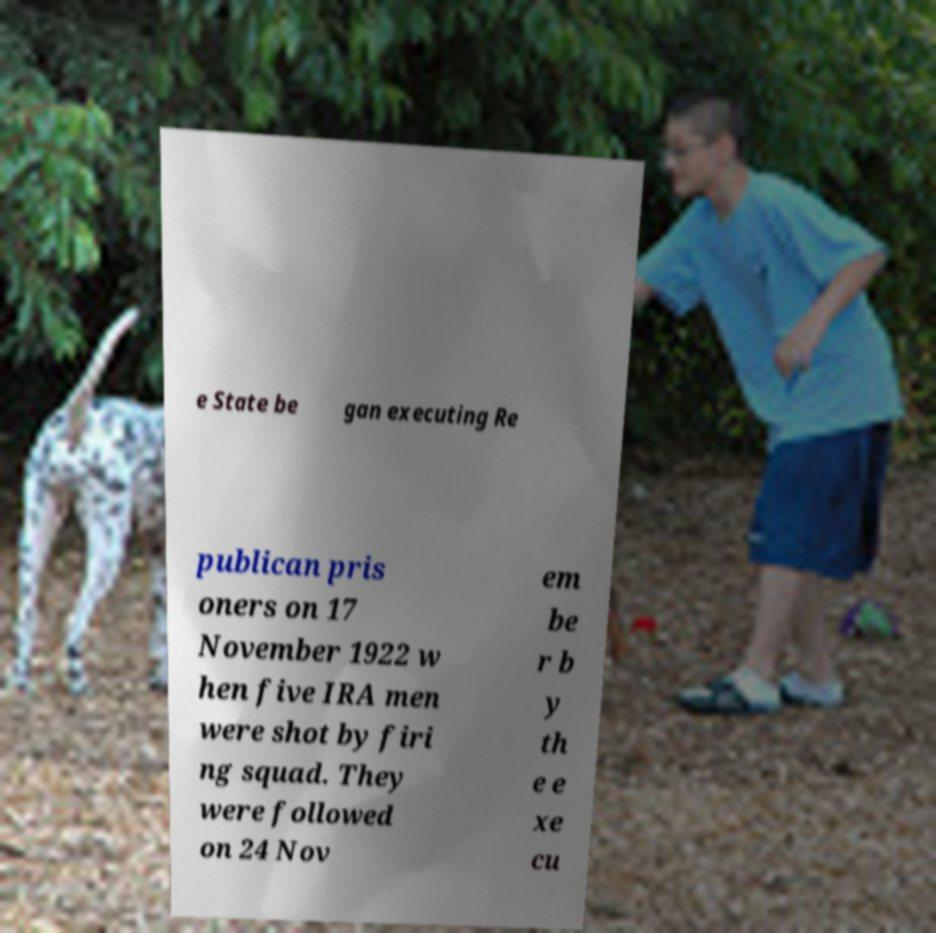I need the written content from this picture converted into text. Can you do that? e State be gan executing Re publican pris oners on 17 November 1922 w hen five IRA men were shot by firi ng squad. They were followed on 24 Nov em be r b y th e e xe cu 